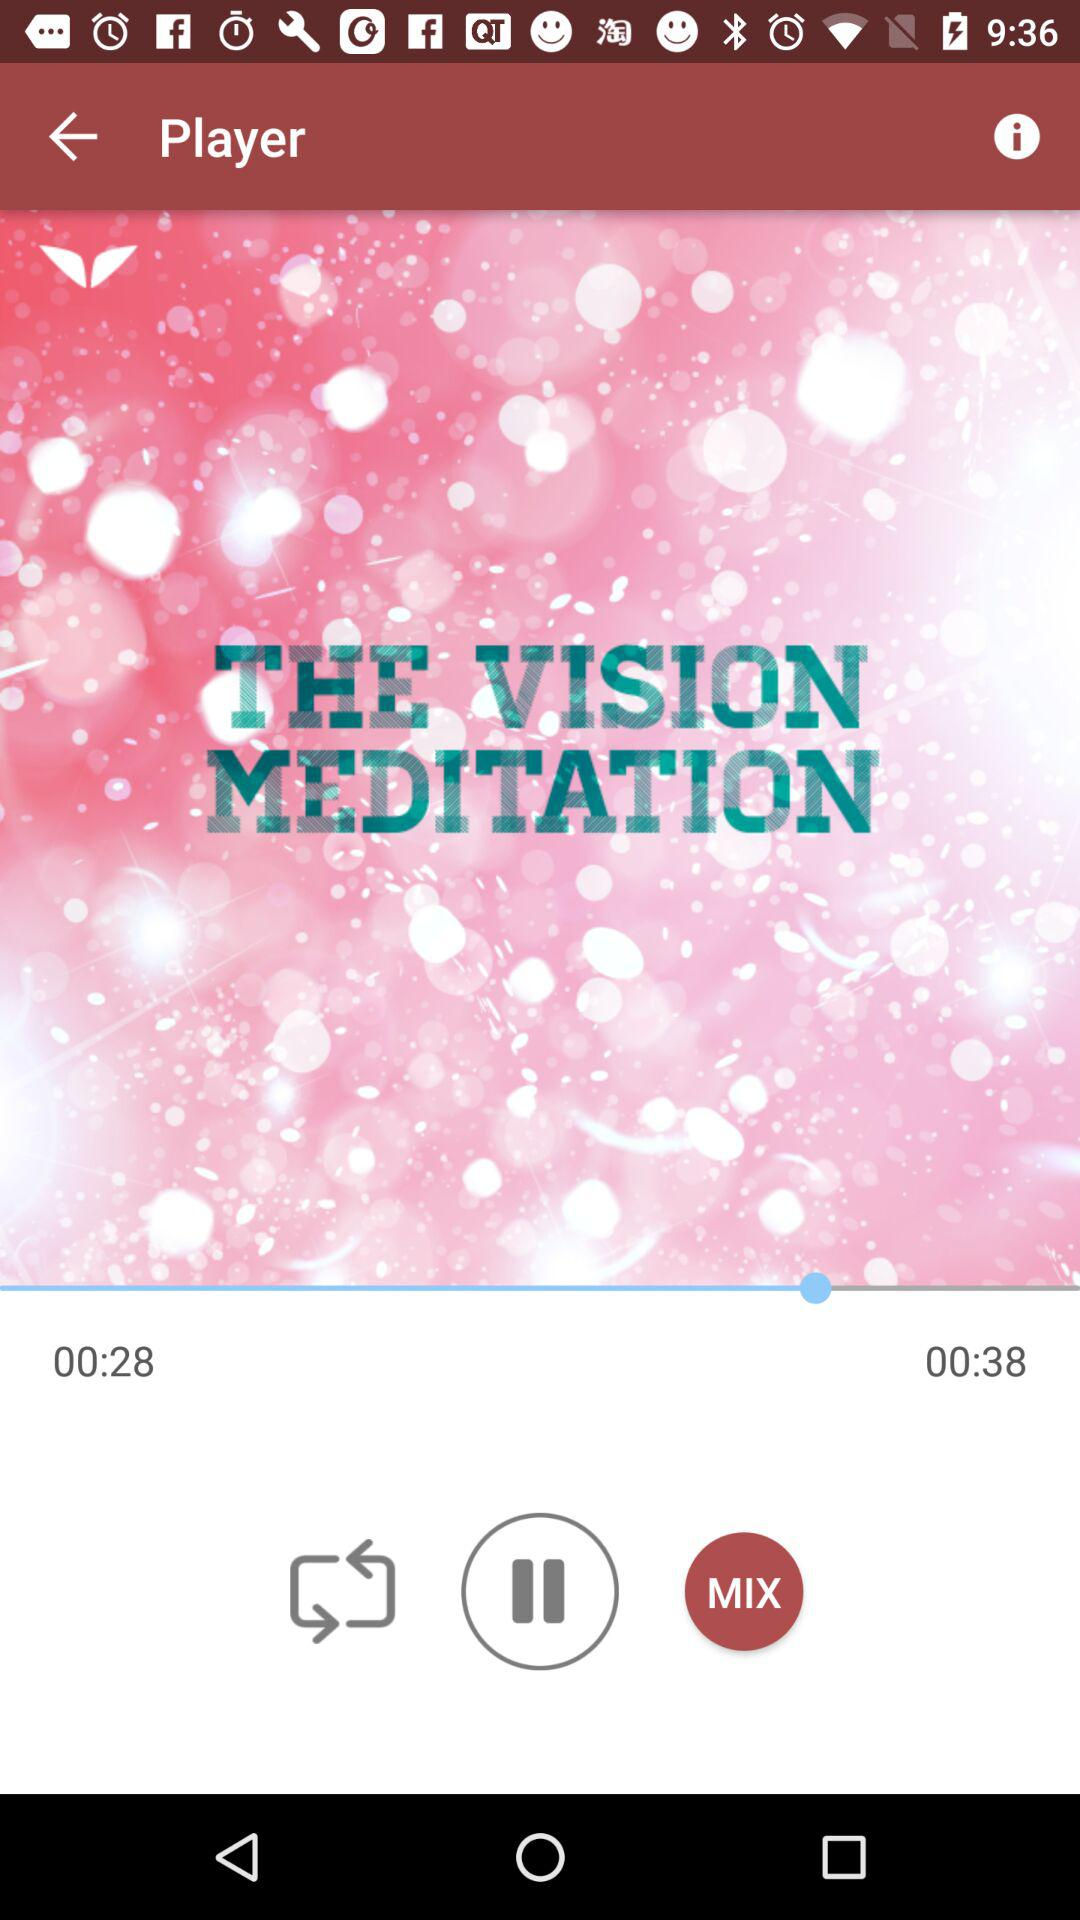What is the duration of the content? The duration is 38 seconds. 